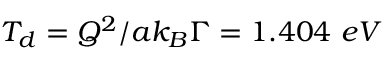<formula> <loc_0><loc_0><loc_500><loc_500>T _ { d } = { Q ^ { 2 } } / { a { k _ { B } } { \Gamma } } = 1 . 4 0 4 e V</formula> 